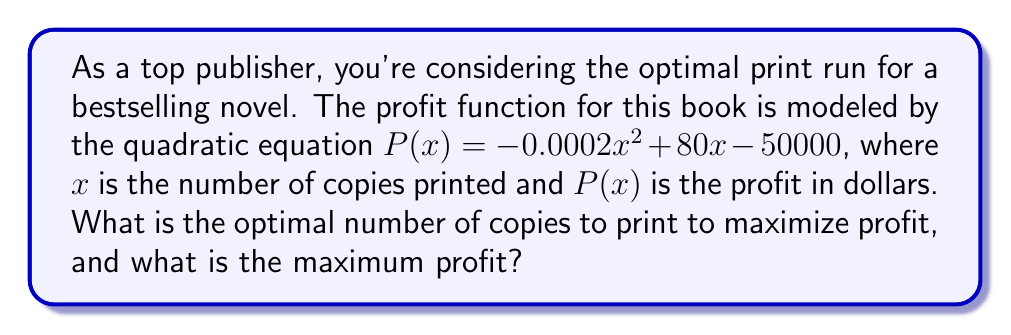What is the answer to this math problem? To find the optimal number of copies and maximum profit, we need to follow these steps:

1) The profit function is a quadratic equation in the form $P(x) = ax^2 + bx + c$, where:
   $a = -0.0002$
   $b = 80$
   $c = -50000$

2) For a quadratic function, the x-coordinate of the vertex represents the optimal value of x (number of copies) that maximizes the function. We can find this using the formula:

   $x = -\frac{b}{2a}$

3) Substituting our values:

   $x = -\frac{80}{2(-0.0002)} = \frac{80}{0.0004} = 200,000$

4) To find the maximum profit, we substitute this x-value back into our original equation:

   $P(200000) = -0.0002(200000)^2 + 80(200000) - 50000$
               $= -0.0002(40000000000) + 16000000 - 50000$
               $= -8000000 + 16000000 - 50000$
               $= 7950000$

Therefore, the optimal number of copies to print is 200,000, and the maximum profit is $7,950,000.
Answer: 200,000 copies; $7,950,000 